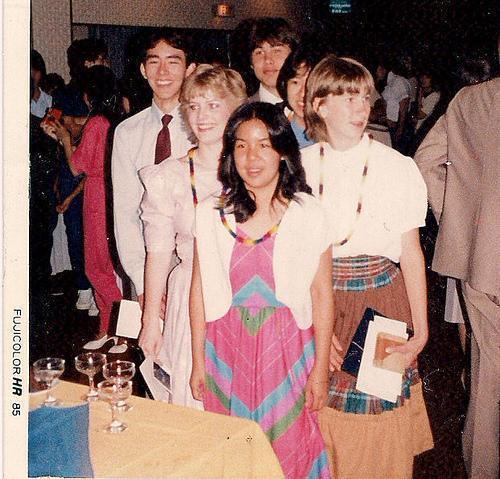How many people are there?
Give a very brief answer. 9. 